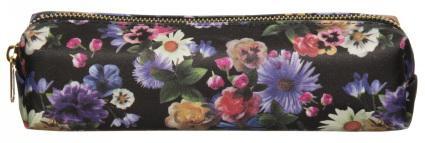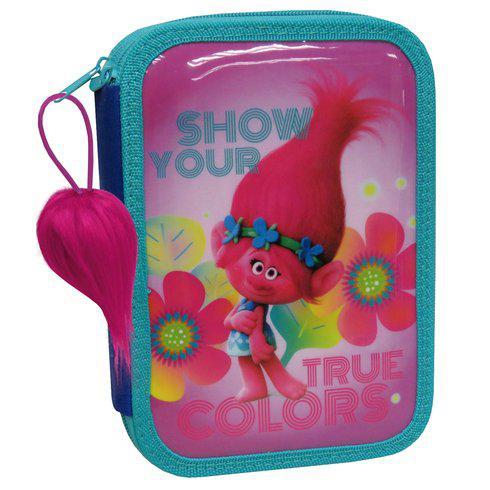The first image is the image on the left, the second image is the image on the right. Given the left and right images, does the statement "No case is displayed open, and at least one rectangular case with rounded corners and hot pink color scheme is displayed standing on its long side." hold true? Answer yes or no. No. The first image is the image on the left, the second image is the image on the right. For the images shown, is this caption "The pencil case to the left contains a lot of the color pink." true? Answer yes or no. No. 